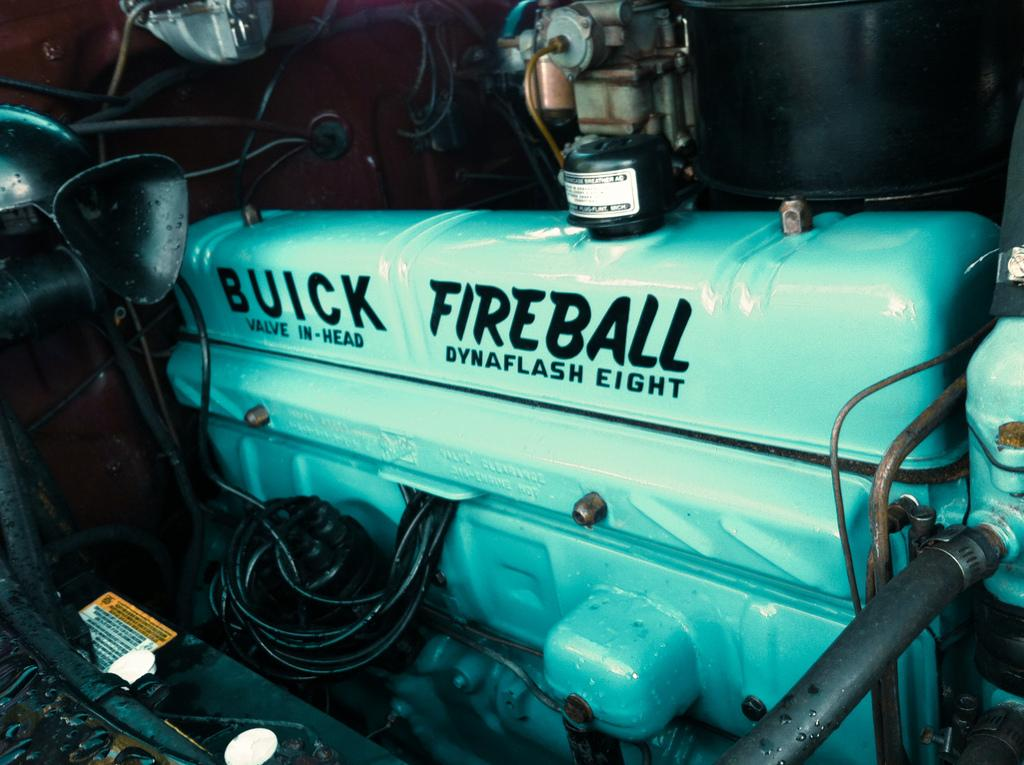What type of location is depicted in the image? The image is an inside part of a vehicle. What specific components can be seen in the image? There are pipes, a rod, an engine, text, a petrol tank, and a board visible in the image. What might be used for fueling the vehicle? The petrol tank is present in the image for fueling the vehicle. What other objects are present in the image? There are other objects present in the image, but their specific details are not mentioned in the provided facts. What type of quill is being used to write on the board in the image? There is no quill present in the image; it is a vehicle interior with various components and objects. What type of destruction is visible in the image? There is no destruction present in the image; it is a vehicle interior with various components and objects. 